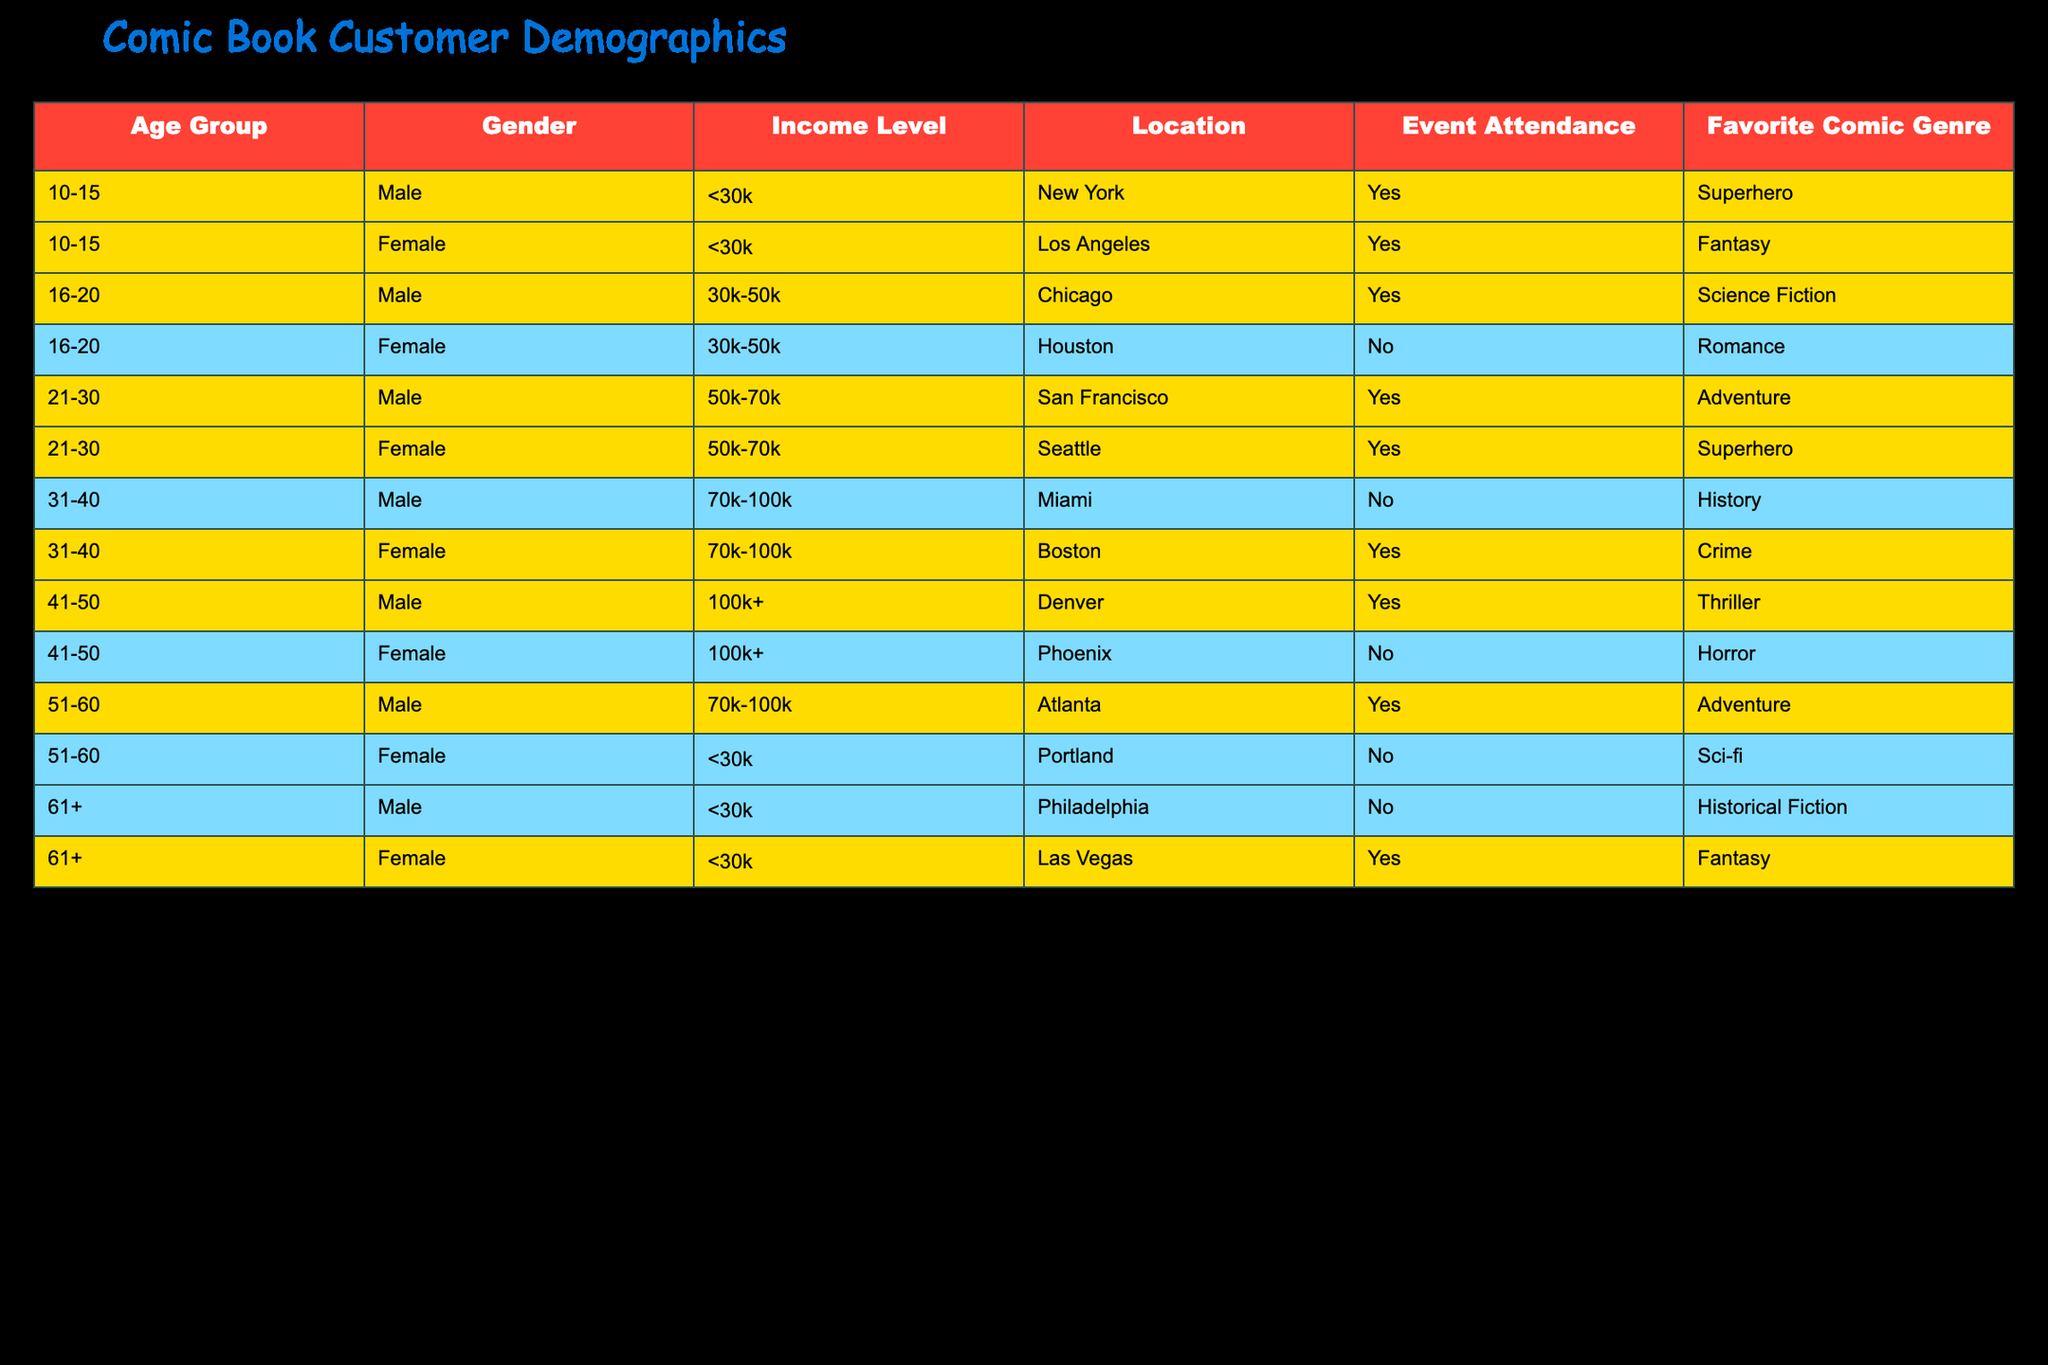What's the favorite comic genre for the majority of 10-15-year-old customers? Looking at the table, the clear favorite comic genre among 10-15-year-olds is Superhero, as there are two entries: one male and one female, both indicating Superhero as their preferred genre.
Answer: Superhero How many males attended events in the 21-30 age group? From the table, the entries for the 21-30 age group show that one male attended an event (San Francisco) while there is no other male listed. Therefore, the total count of males attending events in this age group is one.
Answer: 1 Which income level has the highest number of event attendees? Analyzing the table, we need to count the event attendees based on income levels. The counts are as follows: <30k has two attendees (New York and Los Angeles), 30k-50k has one (Chicago), and both 50k-70k and 70k-100k have two each. However, 100k+ has two attendees (Denver and Phoenix). The highest count is for the income level <30k and 100k+ at two each.
Answer: <30k and 100k+ Is there a female attendee from Phoenix in the 41-50 age group? According to the table, there is a female from Phoenix who belongs to the 41-50 age group but did not attend the event (indicated by "No"). So, the statement is true.
Answer: Yes What is the total number of attendees over the age of 50? Looking through the table, we can recognize the two age groups over 50: 51-60 has one male and one female attendee (Atlanta and Portland), and 61+ has one male and one female attendee (Philadelphia and Las Vegas). Thus, to find the total, we sum these: 1 (51-60 male) + 1 (51-60 female) + 1 (61+ male) + 1 (61+ female) = 4 attendees.
Answer: 4 What percentage of female attendees enjoys the Adventure genre, based on the data? In the table, there are a total of four female attendees: two (Superhero and Fantasy genres) enjoy the Adventure genre. To calculate the percentage: (number of females who enjoy Adventure / total female attendees) * 100 = (1 / 4) * 100 = 25%.
Answer: 25% How many attendees did not attend any events? By reviewing the table, we find non-attendees listed: one female from Houston, one male from Miami, one female from Portland, and one male from Philadelphia, adding up to a total of four non-attendees.
Answer: 4 What is the favorite comic genre for the 31-40 age group males? Across the table, for the 31-40 age group males, the only data point listed indicates that the favorite comic genre is History.
Answer: History 